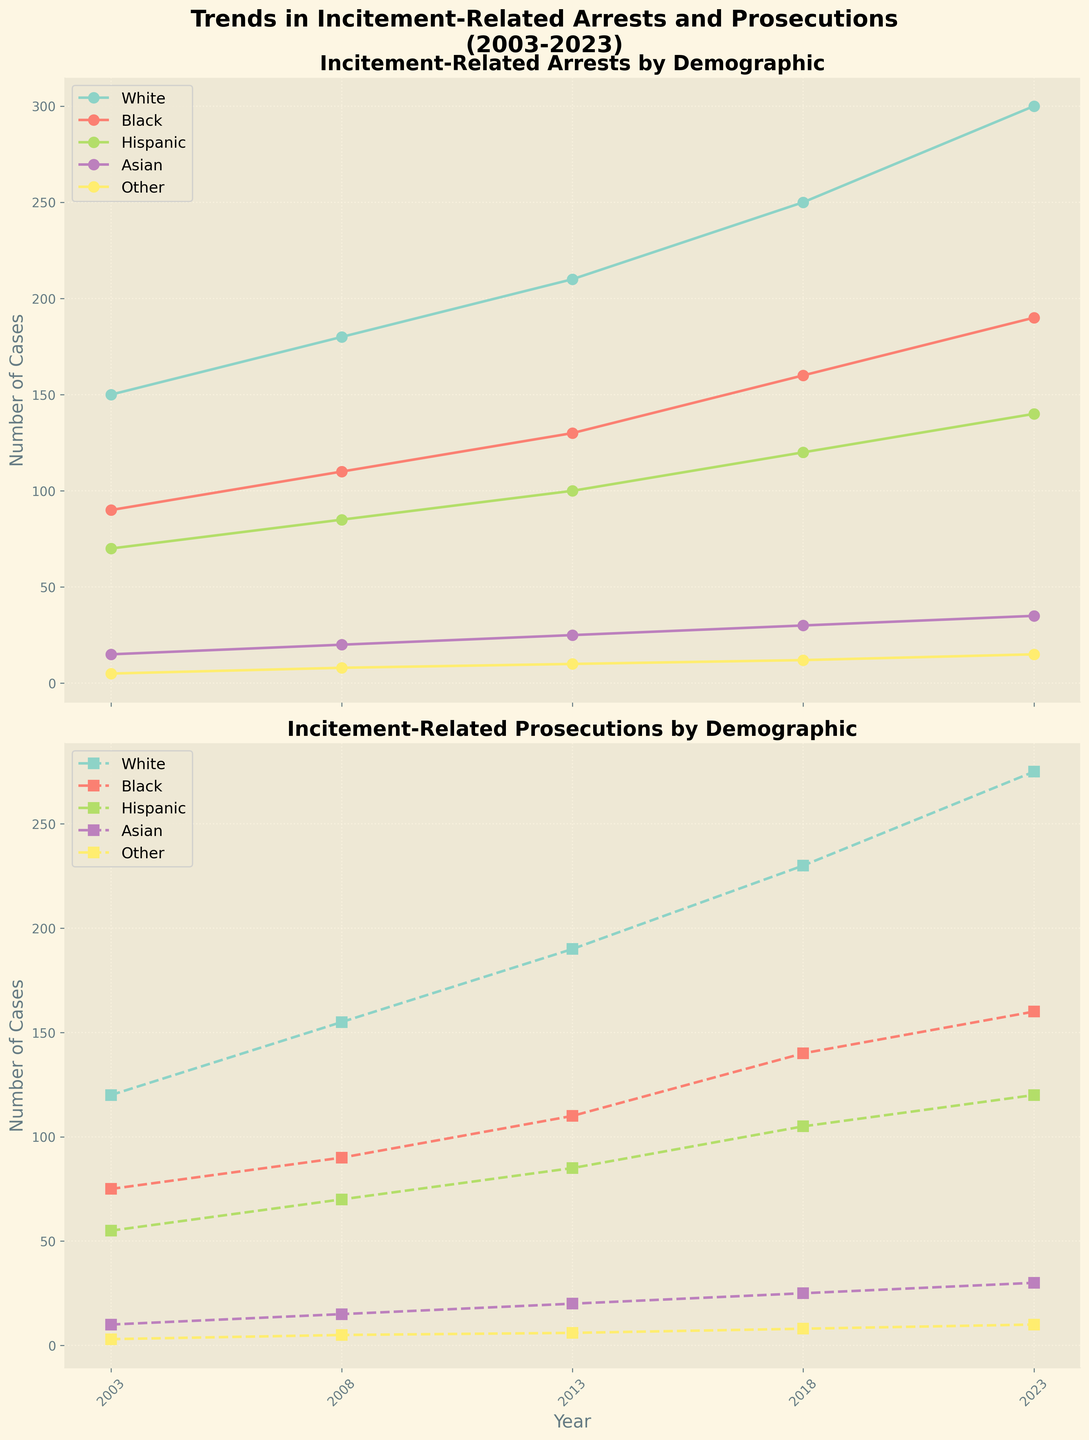What is the title of the top subplot? The title of the top subplot can be found directly above the graph it pertains to. It reads, "Incitement-Related Arrests by Demographic," indicating the demographic breakdown of incitement-related arrests over time.
Answer: Incitement-Related Arrests by Demographic Which demographic had the most incitement-related arrests in 2023? To answer this, one must look at the incitement-related arrests data for 2023 across all demographics. The group with the highest data point in 2023 is the "White" demographic with 300 arrests.
Answer: White What are the two demographics with the lowest number of incitement-related prosecutions in 2003? By examining the incitement-related prosecutions data for 2003, the two demographics with the lowest numbers are "Asian" (10 prosecutions) and "Other" (3 prosecutions).
Answer: Asian and Other How many total incitement-related prosecutions were there in 2018? To find the total, sum the number of prosecutions across all demographics for 2018: 230 (White) + 140 (Black) + 105 (Hispanic) + 25 (Asian) + 8 (Other) = 508.
Answer: 508 Which demographic showed the most significant increase in incitement-related arrests from 2003 to 2023? To determine this, calculate the difference in arrests between 2003 and 2023 for each demographic and find the largest difference. The increases are: 
White: 300 - 150 = 150
Black: 190 - 90 = 100
Hispanic: 140 - 70 = 70
Asian: 35 - 15 = 20
Other: 15 - 5 = 10
The "White" demographic had the most significant increase of 150 arrests.
Answer: White Which year had the highest number of incitement-related prosecutions for the Hispanic demographic? Reference the incitement-related prosecutions data for the Hispanic demographic across all years. The year 2023 has the highest number with 120 prosecutions.
Answer: 2023 Is there a trend in the incitement-related arrests for the Black demographic over the 20 years period? Observing the Black demographic's arrests from 2003 (90), 2008 (110), 2013 (130), 2018 (160), to 2023 (190), there is a noticeable increasing trend over the 20 years.
Answer: Increasing trend Compare the incitement-related arrests and prosecutions for the Asian demographic in 2008. Which is higher? For the Asian demographic in 2008, there were 20 arrests and 15 prosecutions. Comparing these values, the arrests are higher.
Answer: Arrests What's the difference between the number of prosecutions for the White demographic in 2003 and 2023? To find the difference, subtract the number of prosecutions in 2003 from that in 2023: 275 (2023) - 120 (2003) = 155.
Answer: 155 How did the number of incitement-related arrests for the Hispanic demographic change from 2008 to 2018? Calculate the change in arrests for the Hispanic demographic between 2008 and 2018: 120 (2018) - 85 (2008) = 35. There is an increase of 35 arrests.
Answer: Increased by 35 